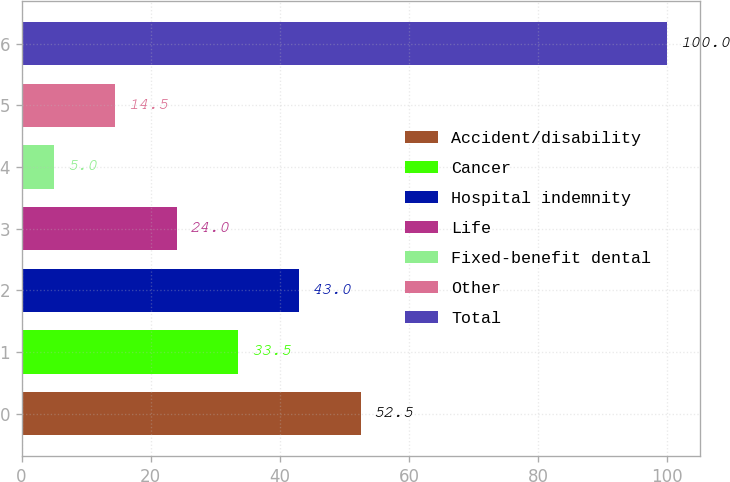Convert chart. <chart><loc_0><loc_0><loc_500><loc_500><bar_chart><fcel>Accident/disability<fcel>Cancer<fcel>Hospital indemnity<fcel>Life<fcel>Fixed-benefit dental<fcel>Other<fcel>Total<nl><fcel>52.5<fcel>33.5<fcel>43<fcel>24<fcel>5<fcel>14.5<fcel>100<nl></chart> 